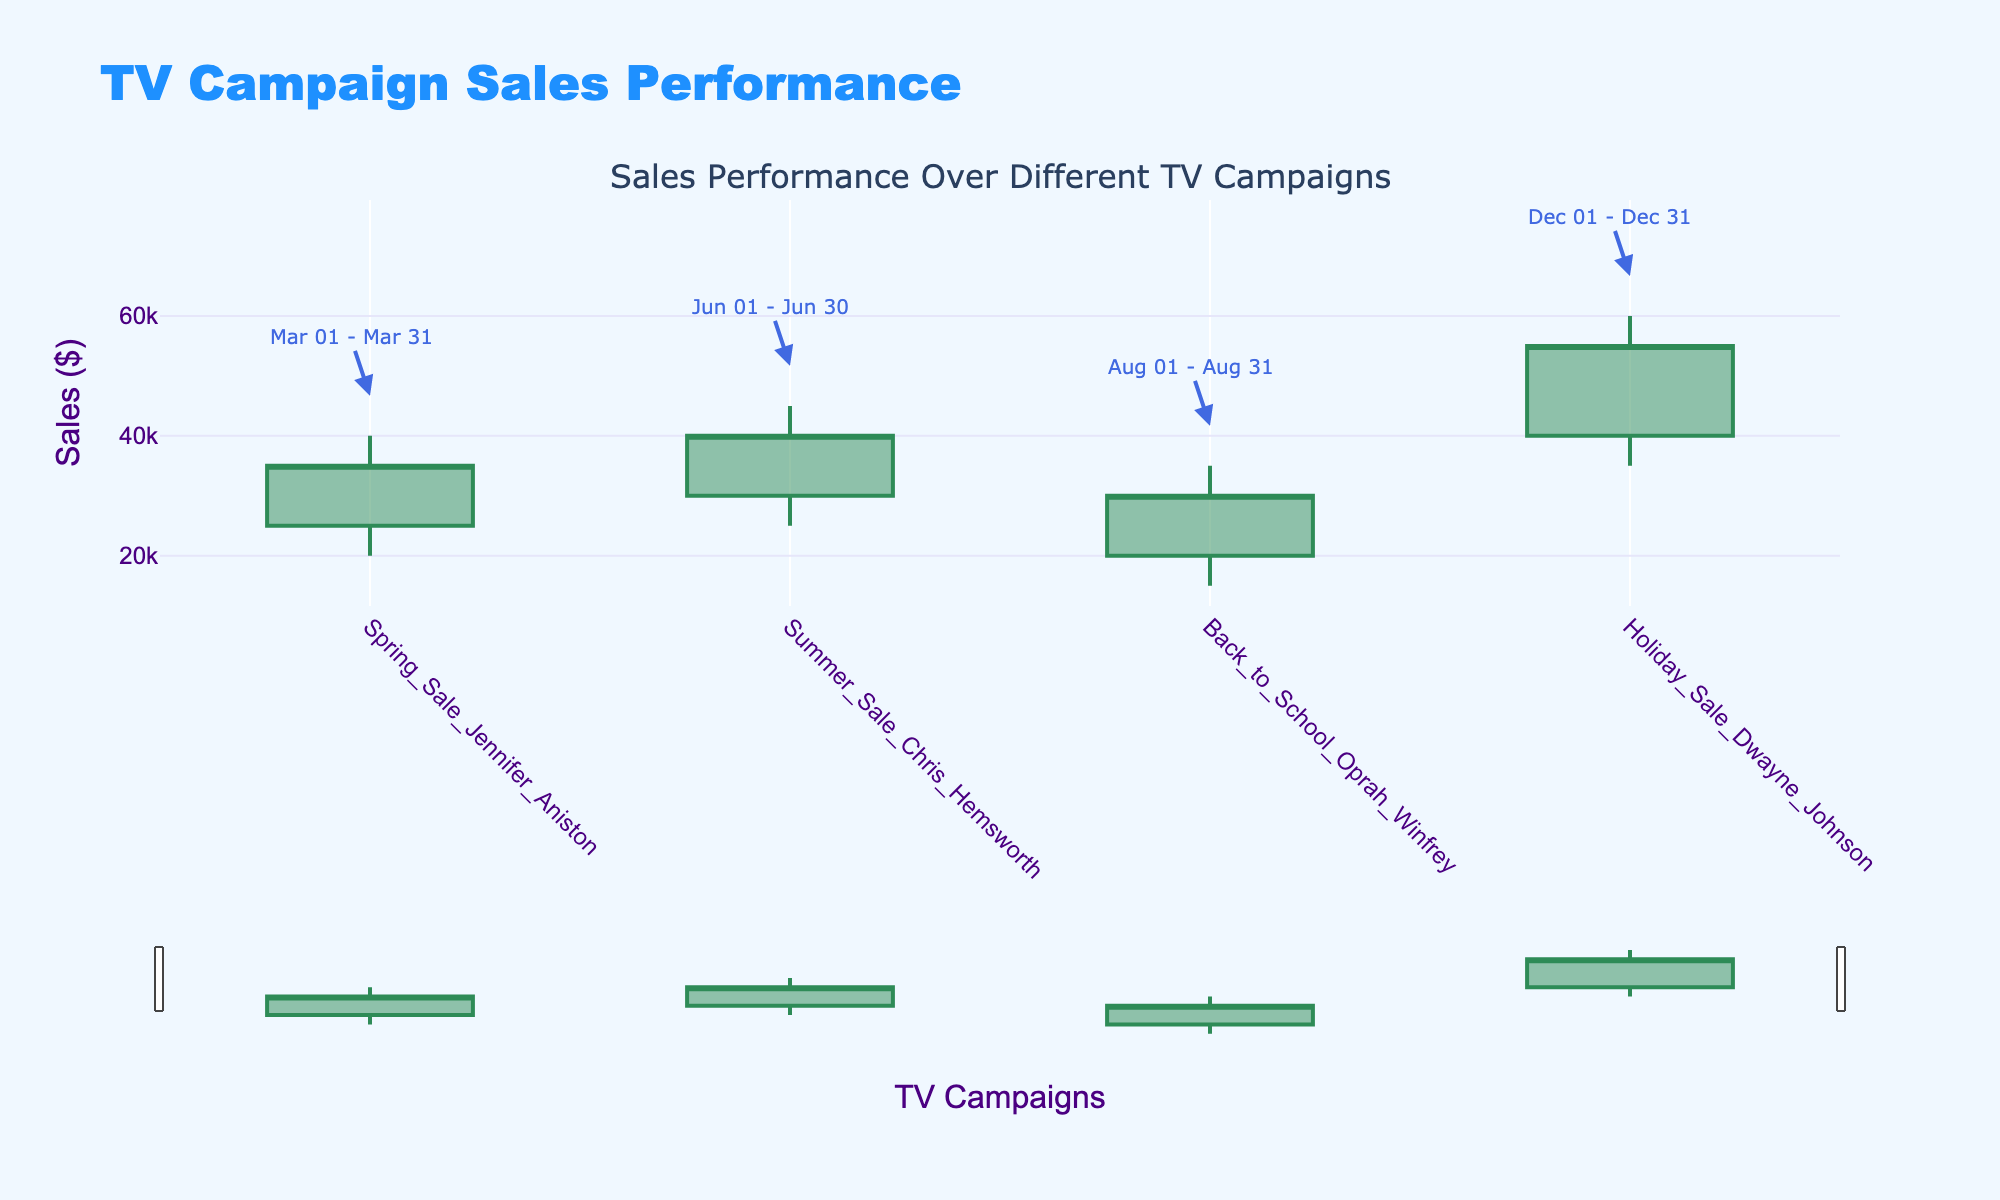What's the title of the figure? The title of the figure is prominently displayed at the top, and it states the purpose of the figure.
Answer: TV Campaign Sales Performance How many campaigns are displayed in the plot? The x-axis shows different campaigns, each represented by a candlestick. Counting these will give the total number of campaigns.
Answer: 4 Which campaign had the highest sales peak? Identify the candlestick with the highest upper wick, which represents the highest sales.
Answer: Holiday Sale Dwayne Johnson What is the date range for the Spring Sale Jennifer Aniston campaign? There are date annotations above the highest point of each candlestick, providing start and end dates for each campaign.
Answer: Mar 01 - Mar 31 What's the difference between the highest and lowest sales in the Summer Sale Chris Hemsworth campaign? Look at the highest and lowest points of the Summer Sale Chris Hemsworth candlestick and subtract the lowest from the highest.
Answer: 20000 Which campaign had the smallest range between the highest and lowest sales? Compare the range of the highest to lowest points for each campaign and identify the smallest.
Answer: Back to School Oprah Winfrey Did the Holiday Sale Dwayne Johnson campaign have an increase or decrease in sales by the end? Compare the opening sales (bottom of the thicker part of the candlestick) to the closing sales (top of the thicker part) of the Holiday Sale Dwayne Johnson candlestick.
Answer: Increase Which campaign had the greatest increase in sales from opening to closing? Determine the difference between opening and closing sales for each campaign and find the maximum.
Answer: Summer Sale Chris Hemsworth What is the combined opening sales for all campaigns? Sum the opening sales values for all the campaigns. Calculation: 25000 + 30000 + 20000 + 40000.
Answer: 115000 During which campaign was the lowest sales recorded? Identify the candlestick with the lowest bottom wick, representing the minimum sales.
Answer: Back to School Oprah Winfrey 